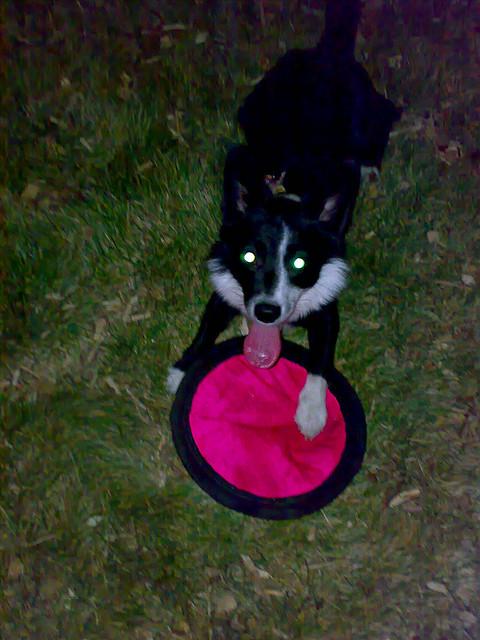What color are the dogs teeth?
Give a very brief answer. White. Why are the animal's eyes glowing?
Write a very short answer. Flash reflecting. What type of dog is shown?
Give a very brief answer. Husky. What animal is this?
Concise answer only. Dog. Did the dog catch the frisbee?
Give a very brief answer. Yes. 